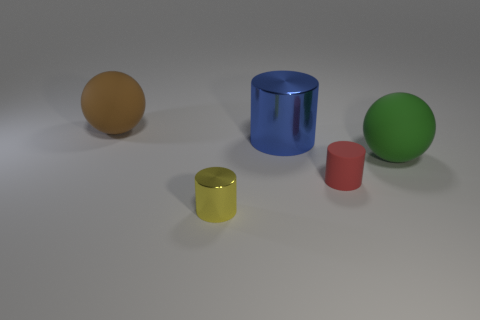Add 5 yellow metal things. How many objects exist? 10 Subtract all cylinders. How many objects are left? 2 Subtract 0 green cylinders. How many objects are left? 5 Subtract all brown matte blocks. Subtract all large brown balls. How many objects are left? 4 Add 2 yellow metal objects. How many yellow metal objects are left? 3 Add 5 yellow cylinders. How many yellow cylinders exist? 6 